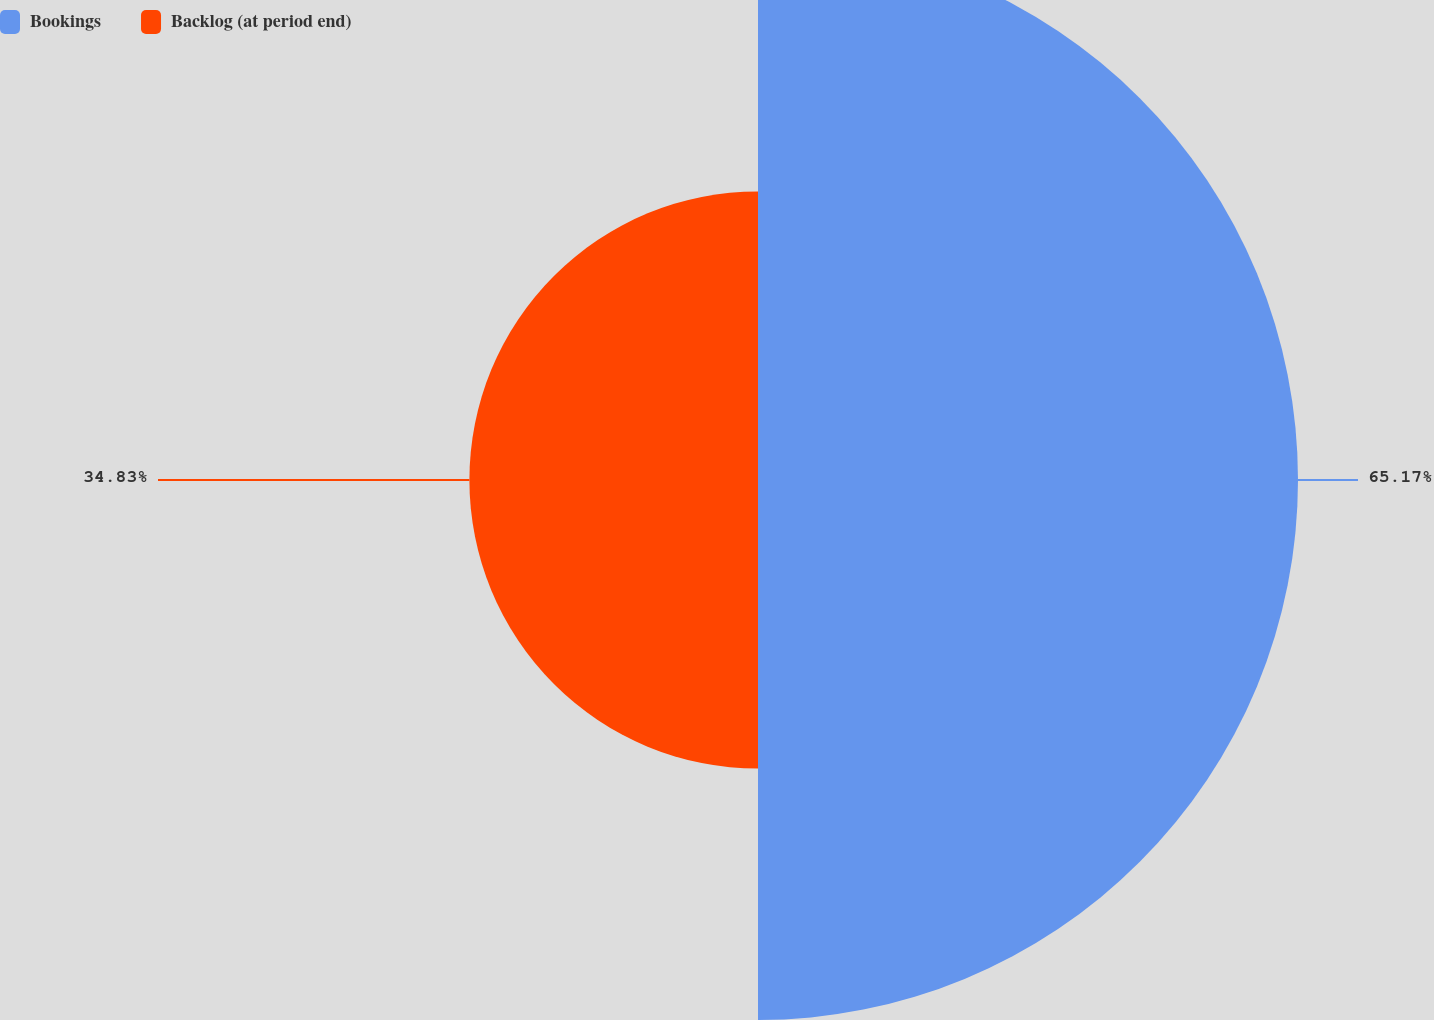Convert chart. <chart><loc_0><loc_0><loc_500><loc_500><pie_chart><fcel>Bookings<fcel>Backlog (at period end)<nl><fcel>65.17%<fcel>34.83%<nl></chart> 